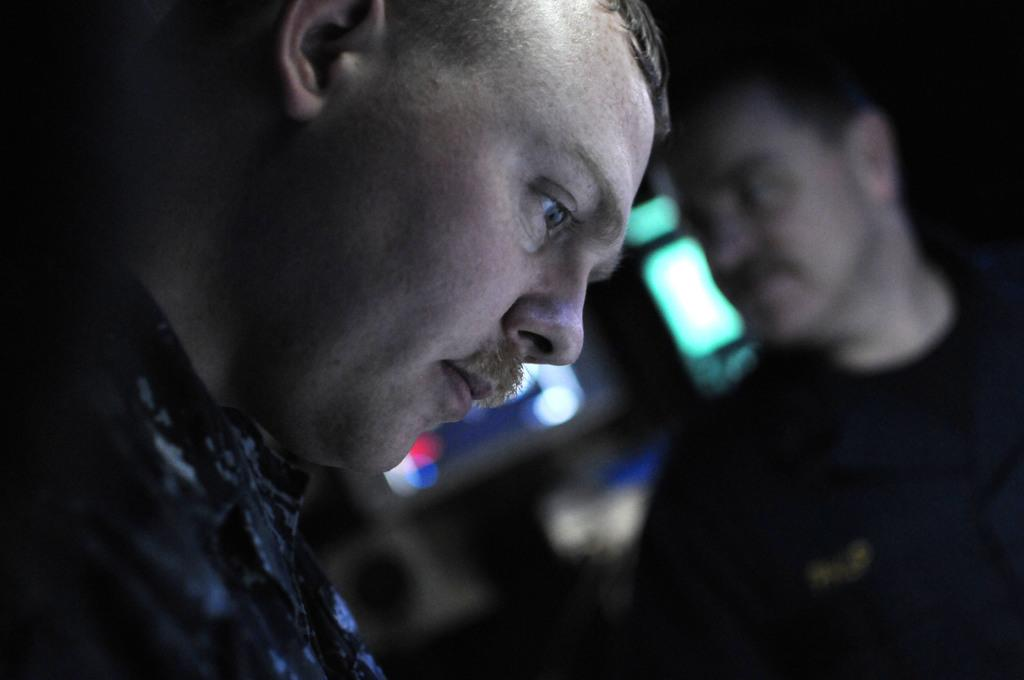How many men are in the image? There are two men in the image. Can you describe the position of the second man? The second man is on the right side of the image. What can be observed about the background and right side of the image? The right side and background have a blurred view. What type of tooth is visible in the middle of the image? There is no tooth present in the image. Can you describe the plane flying in the background of the image? There is no plane visible in the image; it only features two men and a blurred background. 